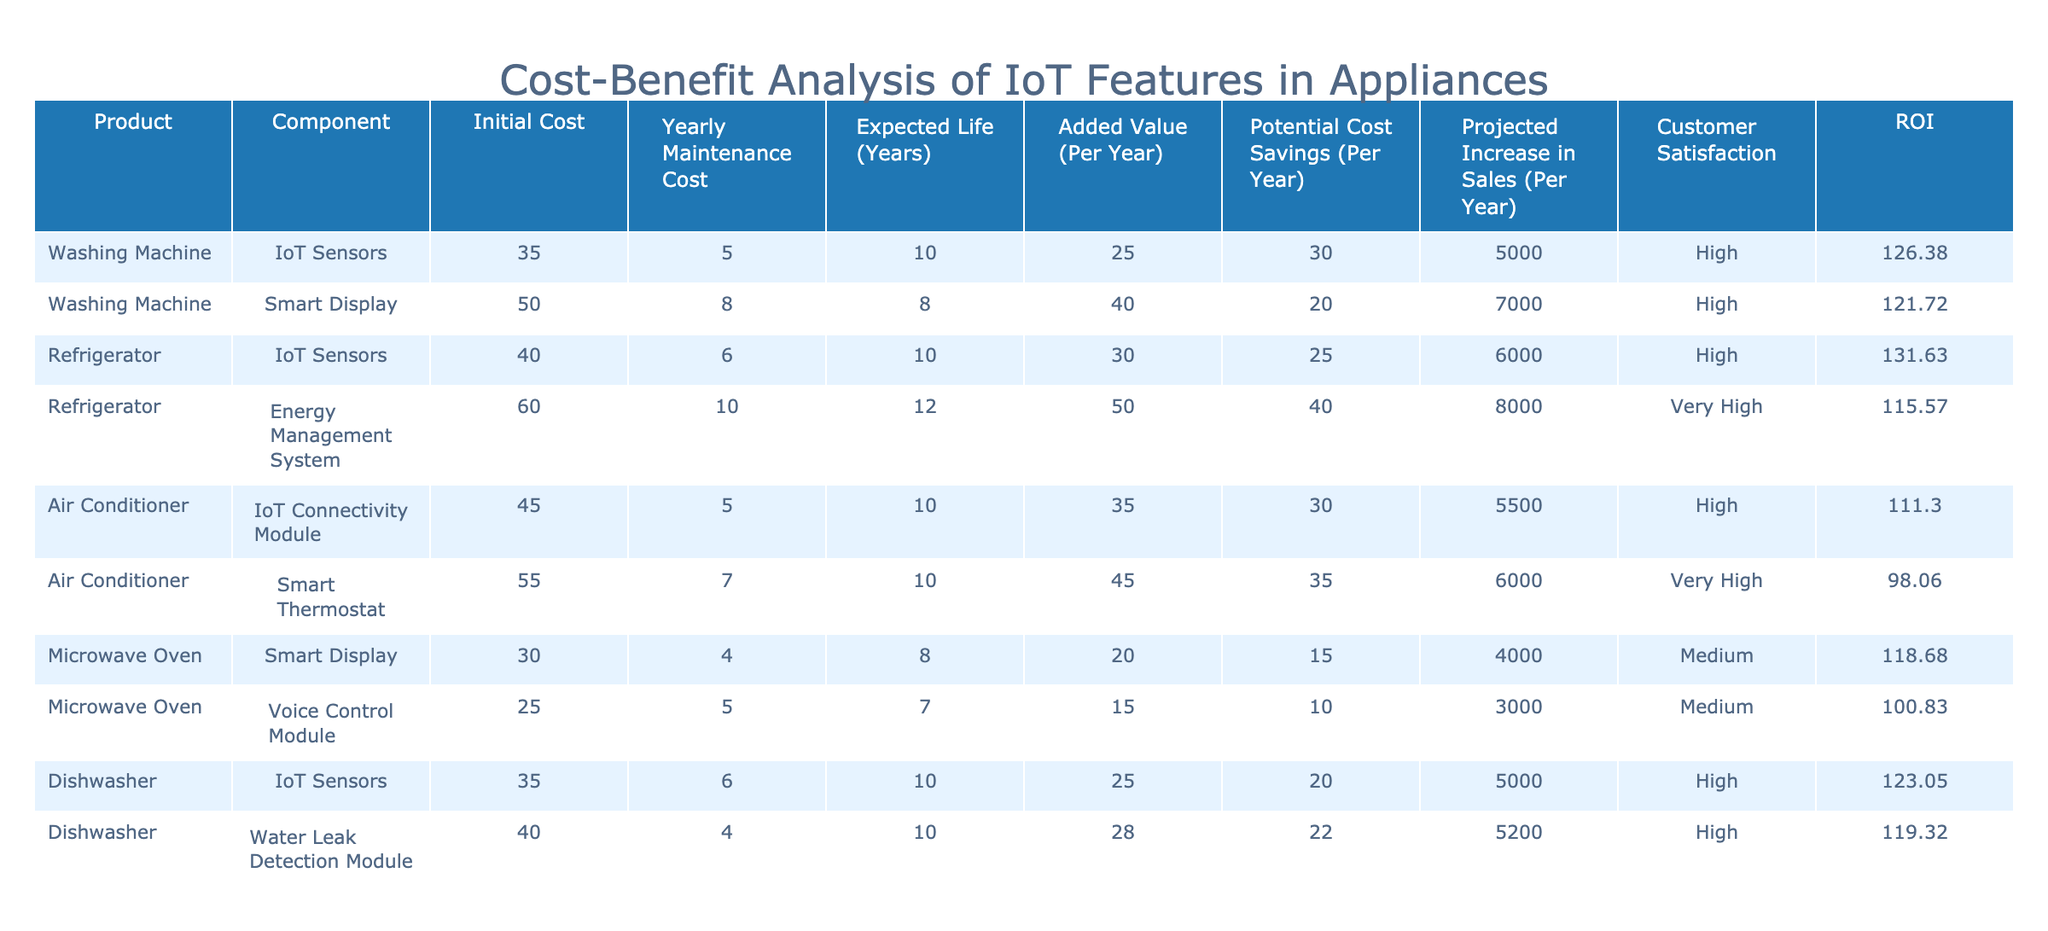What is the initial cost of the Energy Management System for the Refrigerator? The table shows the initial cost for the Energy Management System under the Refrigerator category is 60.
Answer: 60 Which appliance has the highest added value per year? Looking through the Added Value column for each appliance, the Energy Management System shows the highest value of 50, which is higher than any other component listed.
Answer: 50 What is the total projected increase in sales for all Microwave Oven components? By adding the projected increase in sales for both Microwave Oven components, we have 4000 (Smart Display) + 3000 (Voice Control Module) = 7000.
Answer: 7000 Do both Air Conditioner components have a high level of customer satisfaction? The customer satisfaction levels for both components (IoT Connectivity Module and Smart Thermostat) are categorized as High and Very High, therefore both are satisfied.
Answer: Yes Which component of the Washing Machine has a better ROI? The ROI for IoT Sensors is calculated as (25 + 30 + 5000) / (35 + 5) = 100. The ROI for Smart Display is calculated as (40 + 20 + 7000) / (50 + 8) = 113. Both calculations show Smart Display has a better ROI compared to IoT Sensors.
Answer: Smart Display What is the average yearly maintenance cost across all components? First, we sum the yearly maintenance costs: 5 + 8 + 6 + 10 + 5 + 7 + 4 + 5 + 6 + 4 = 60. Then, divide by 10 (the total number of components), resulting in an average of 6.
Answer: 6 Is the initial cost of IoT Sensors in the Dishwasher higher than in the Washing Machine? The initial cost of IoT Sensors in the Dishwasher is 35, while in the Washing Machine it's also 35. Therefore, they are equal.
Answer: No What is the total expected life of all components listed? The expected life for each component is summed as follows: (10 + 8 + 10 + 12 + 10 + 10 + 8 + 7 + 10 + 10) = 88 years.
Answer: 88 How much potential cost savings do the Smart Thermostat provide per year? The table indicates that the Smart Thermostat offers potential cost savings of 35 per year.
Answer: 35 